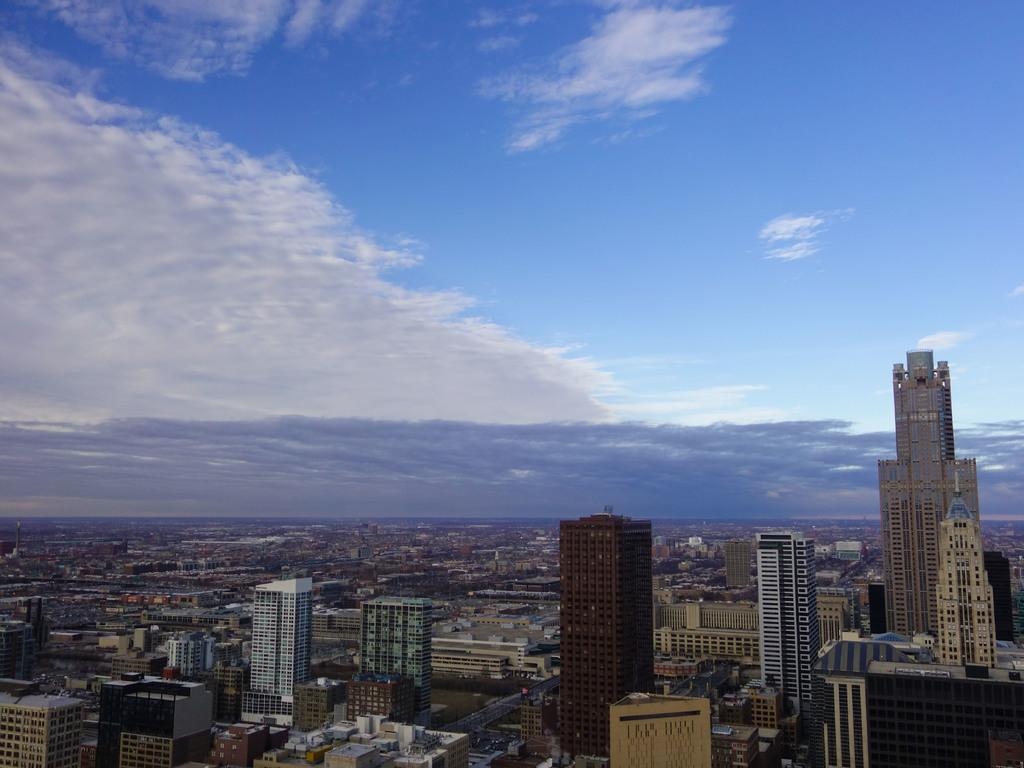What type of structures can be seen at the bottom of the image? There are many buildings at the bottom of the image. What can be seen in the sky at the top of the image? There is a blue sky with clouds at the top of the image. How many dogs are playing with the boy in the image? There are no dogs or boys present in the image; it only features buildings and a blue sky with clouds. 